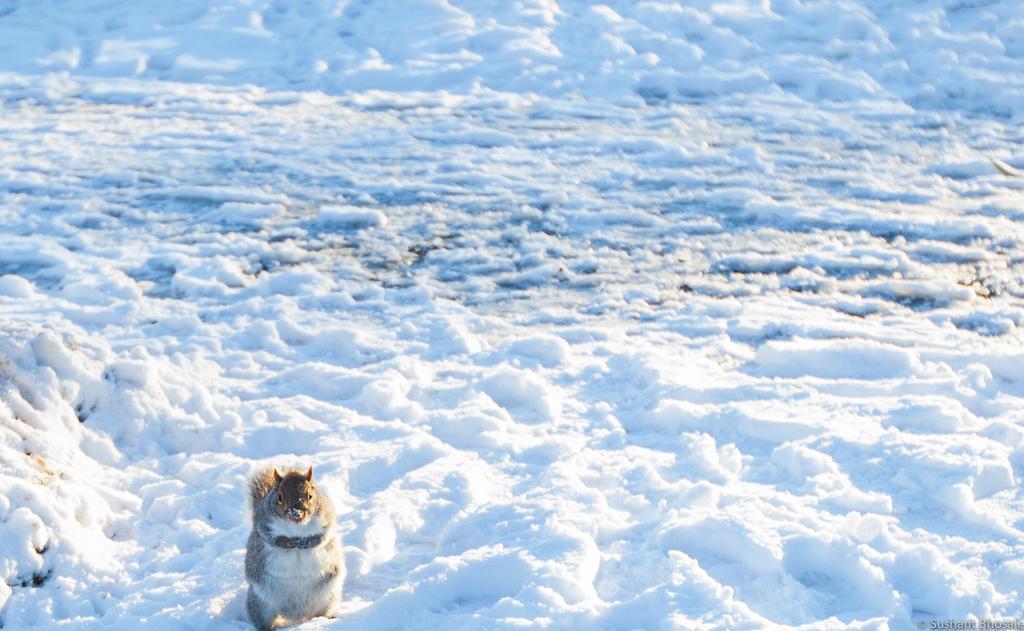Can you describe this image briefly? In this game we can see squirrel on the snow. 